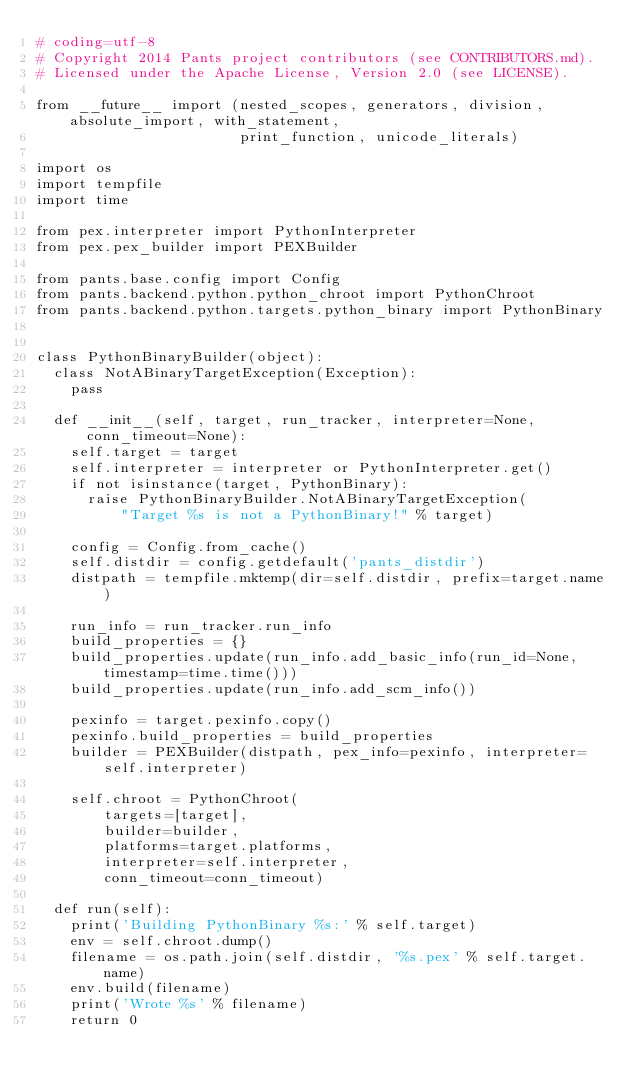<code> <loc_0><loc_0><loc_500><loc_500><_Python_># coding=utf-8
# Copyright 2014 Pants project contributors (see CONTRIBUTORS.md).
# Licensed under the Apache License, Version 2.0 (see LICENSE).

from __future__ import (nested_scopes, generators, division, absolute_import, with_statement,
                        print_function, unicode_literals)

import os
import tempfile
import time

from pex.interpreter import PythonInterpreter
from pex.pex_builder import PEXBuilder

from pants.base.config import Config
from pants.backend.python.python_chroot import PythonChroot
from pants.backend.python.targets.python_binary import PythonBinary


class PythonBinaryBuilder(object):
  class NotABinaryTargetException(Exception):
    pass

  def __init__(self, target, run_tracker, interpreter=None, conn_timeout=None):
    self.target = target
    self.interpreter = interpreter or PythonInterpreter.get()
    if not isinstance(target, PythonBinary):
      raise PythonBinaryBuilder.NotABinaryTargetException(
          "Target %s is not a PythonBinary!" % target)

    config = Config.from_cache()
    self.distdir = config.getdefault('pants_distdir')
    distpath = tempfile.mktemp(dir=self.distdir, prefix=target.name)

    run_info = run_tracker.run_info
    build_properties = {}
    build_properties.update(run_info.add_basic_info(run_id=None, timestamp=time.time()))
    build_properties.update(run_info.add_scm_info())

    pexinfo = target.pexinfo.copy()
    pexinfo.build_properties = build_properties
    builder = PEXBuilder(distpath, pex_info=pexinfo, interpreter=self.interpreter)

    self.chroot = PythonChroot(
        targets=[target],
        builder=builder,
        platforms=target.platforms,
        interpreter=self.interpreter,
        conn_timeout=conn_timeout)

  def run(self):
    print('Building PythonBinary %s:' % self.target)
    env = self.chroot.dump()
    filename = os.path.join(self.distdir, '%s.pex' % self.target.name)
    env.build(filename)
    print('Wrote %s' % filename)
    return 0
</code> 